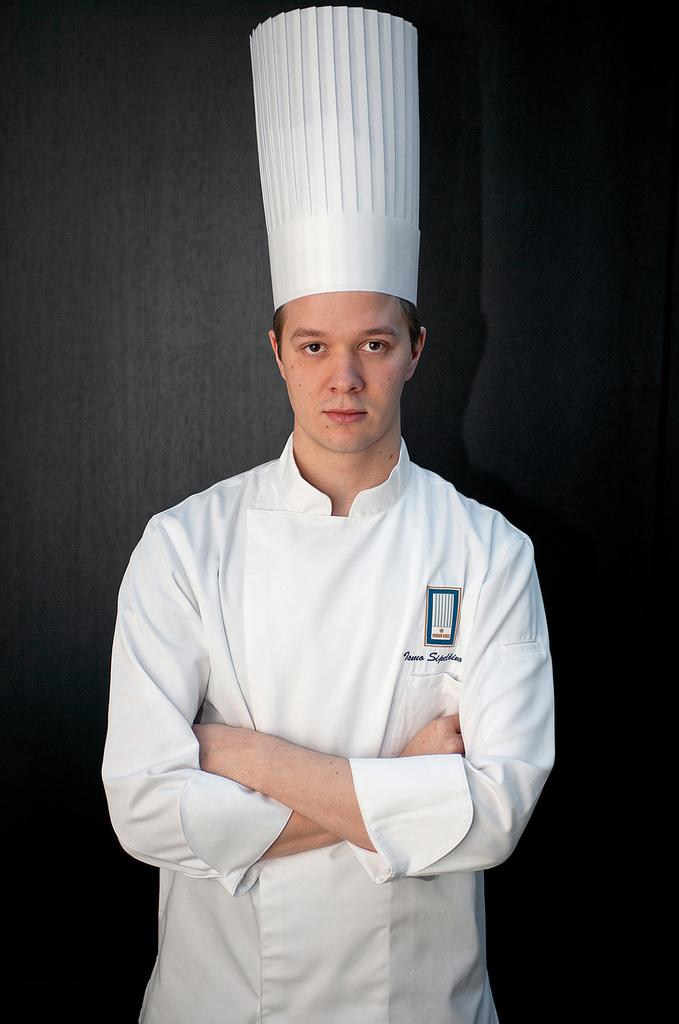Who is the main subject in the image? There is a man standing in the front of the image. What is the man wearing? The man is wearing a chef dress and a chef hat. What color is the wall in the background of the image? The wall in the background of the image is black. How many nuts are on the floor in the image? There are no nuts present in the image. What type of tooth is visible in the image? There are no teeth visible in the image. 